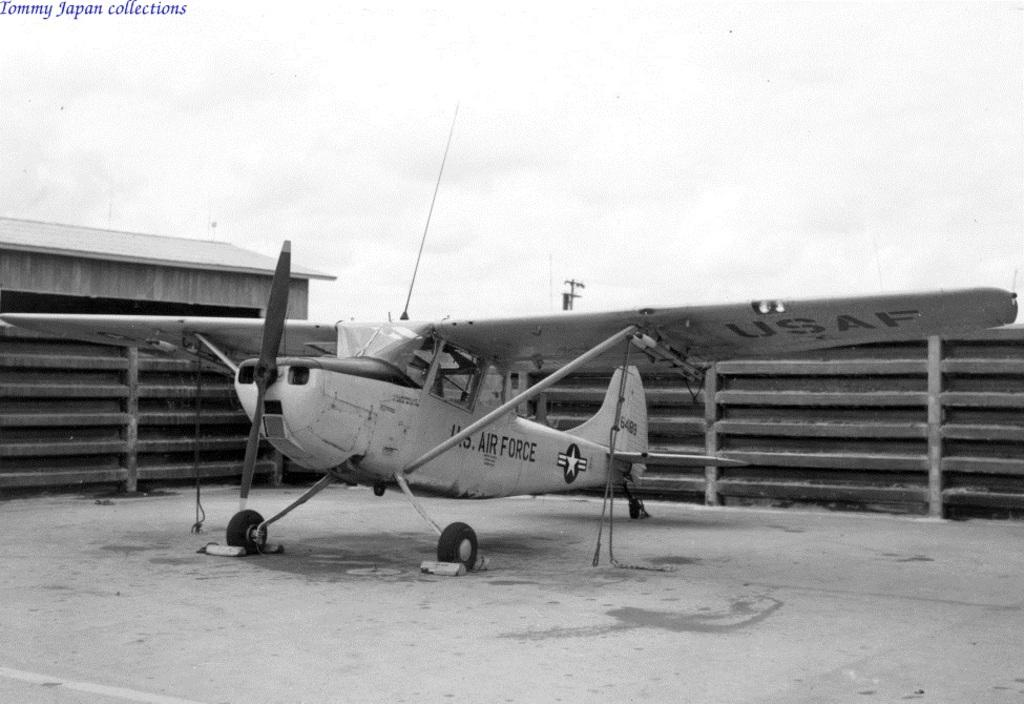<image>
Summarize the visual content of the image. a Tommy Japan Collections US Airforce old airplane. 